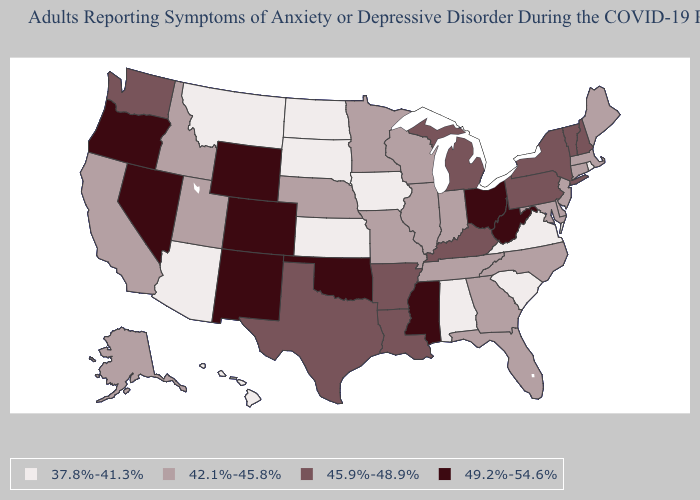What is the value of Indiana?
Answer briefly. 42.1%-45.8%. Does New York have the highest value in the Northeast?
Concise answer only. Yes. What is the value of North Carolina?
Quick response, please. 42.1%-45.8%. What is the lowest value in states that border Wyoming?
Write a very short answer. 37.8%-41.3%. Name the states that have a value in the range 37.8%-41.3%?
Answer briefly. Alabama, Arizona, Hawaii, Iowa, Kansas, Montana, North Dakota, Rhode Island, South Carolina, South Dakota, Virginia. What is the value of Georgia?
Short answer required. 42.1%-45.8%. Does Mississippi have the highest value in the South?
Write a very short answer. Yes. How many symbols are there in the legend?
Short answer required. 4. Name the states that have a value in the range 37.8%-41.3%?
Be succinct. Alabama, Arizona, Hawaii, Iowa, Kansas, Montana, North Dakota, Rhode Island, South Carolina, South Dakota, Virginia. What is the value of Washington?
Give a very brief answer. 45.9%-48.9%. What is the value of Vermont?
Quick response, please. 45.9%-48.9%. Name the states that have a value in the range 37.8%-41.3%?
Concise answer only. Alabama, Arizona, Hawaii, Iowa, Kansas, Montana, North Dakota, Rhode Island, South Carolina, South Dakota, Virginia. What is the highest value in states that border North Carolina?
Give a very brief answer. 42.1%-45.8%. What is the value of Arkansas?
Quick response, please. 45.9%-48.9%. What is the value of New Jersey?
Keep it brief. 42.1%-45.8%. 